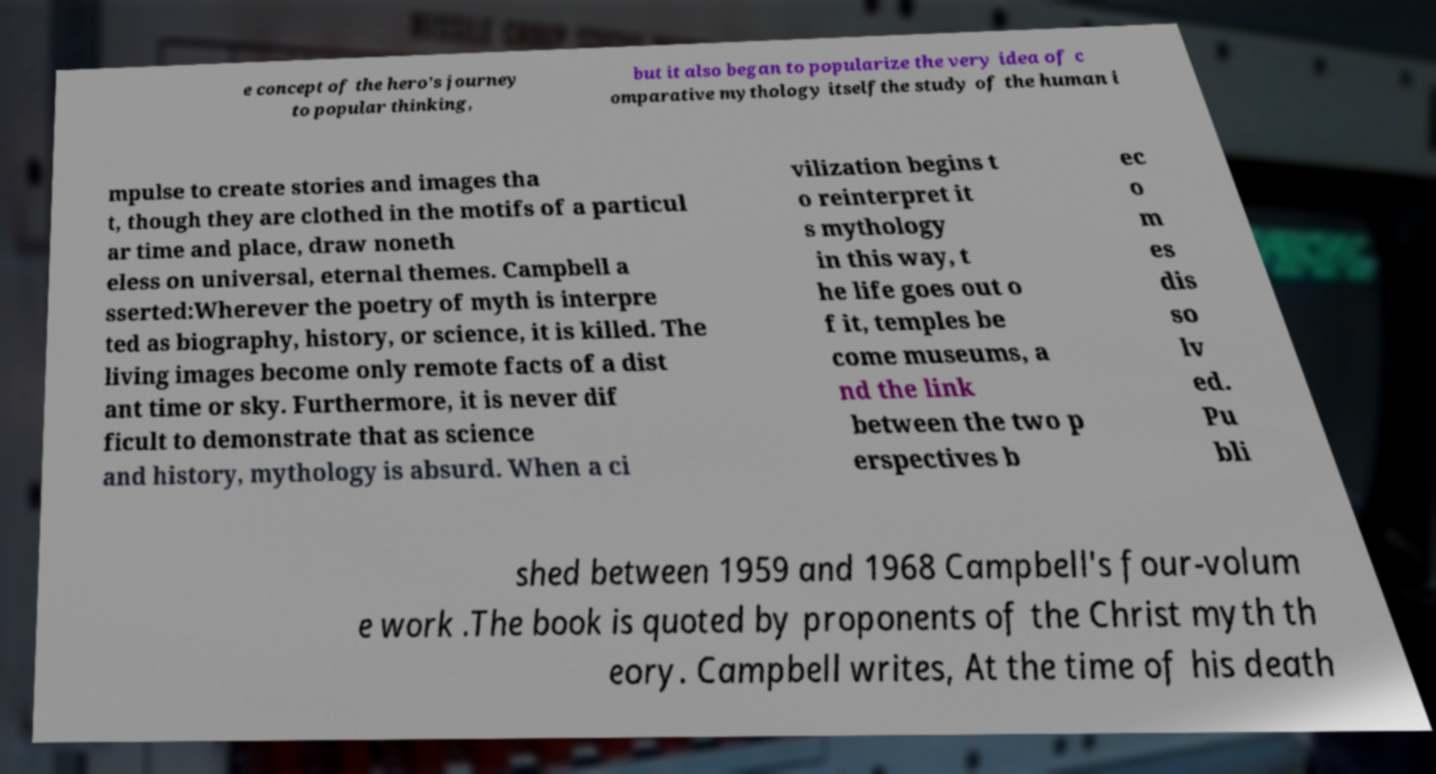Can you accurately transcribe the text from the provided image for me? e concept of the hero's journey to popular thinking, but it also began to popularize the very idea of c omparative mythology itselfthe study of the human i mpulse to create stories and images tha t, though they are clothed in the motifs of a particul ar time and place, draw noneth eless on universal, eternal themes. Campbell a sserted:Wherever the poetry of myth is interpre ted as biography, history, or science, it is killed. The living images become only remote facts of a dist ant time or sky. Furthermore, it is never dif ficult to demonstrate that as science and history, mythology is absurd. When a ci vilization begins t o reinterpret it s mythology in this way, t he life goes out o f it, temples be come museums, a nd the link between the two p erspectives b ec o m es dis so lv ed. Pu bli shed between 1959 and 1968 Campbell's four-volum e work .The book is quoted by proponents of the Christ myth th eory. Campbell writes, At the time of his death 